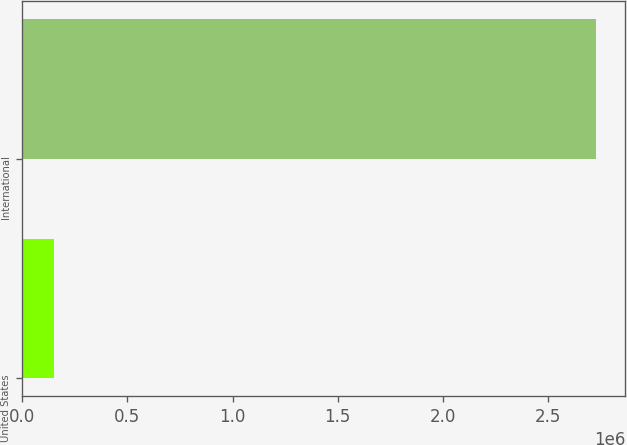Convert chart to OTSL. <chart><loc_0><loc_0><loc_500><loc_500><bar_chart><fcel>United States<fcel>International<nl><fcel>148773<fcel>2.73038e+06<nl></chart> 